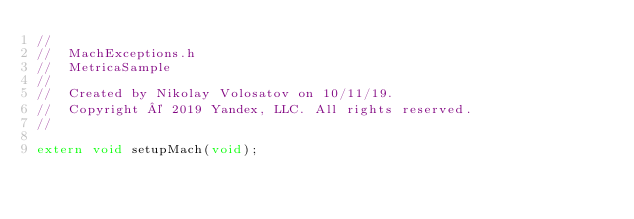Convert code to text. <code><loc_0><loc_0><loc_500><loc_500><_C_>//
//  MachExceptions.h
//  MetricaSample
//
//  Created by Nikolay Volosatov on 10/11/19.
//  Copyright © 2019 Yandex, LLC. All rights reserved.
//

extern void setupMach(void);
</code> 